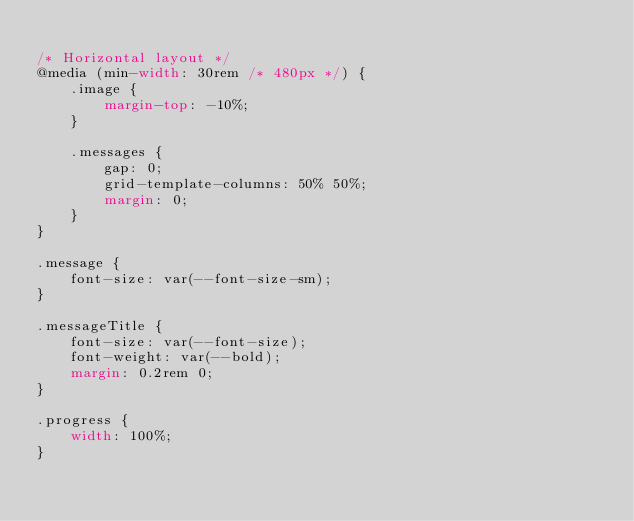<code> <loc_0><loc_0><loc_500><loc_500><_CSS_>
/* Horizontal layout */
@media (min-width: 30rem /* 480px */) {
    .image {
        margin-top: -10%;
    }

    .messages {
        gap: 0;
        grid-template-columns: 50% 50%;
        margin: 0;
    }
}

.message {
    font-size: var(--font-size-sm);
}

.messageTitle {
    font-size: var(--font-size);
    font-weight: var(--bold);
    margin: 0.2rem 0;
}

.progress {
    width: 100%;
}
</code> 